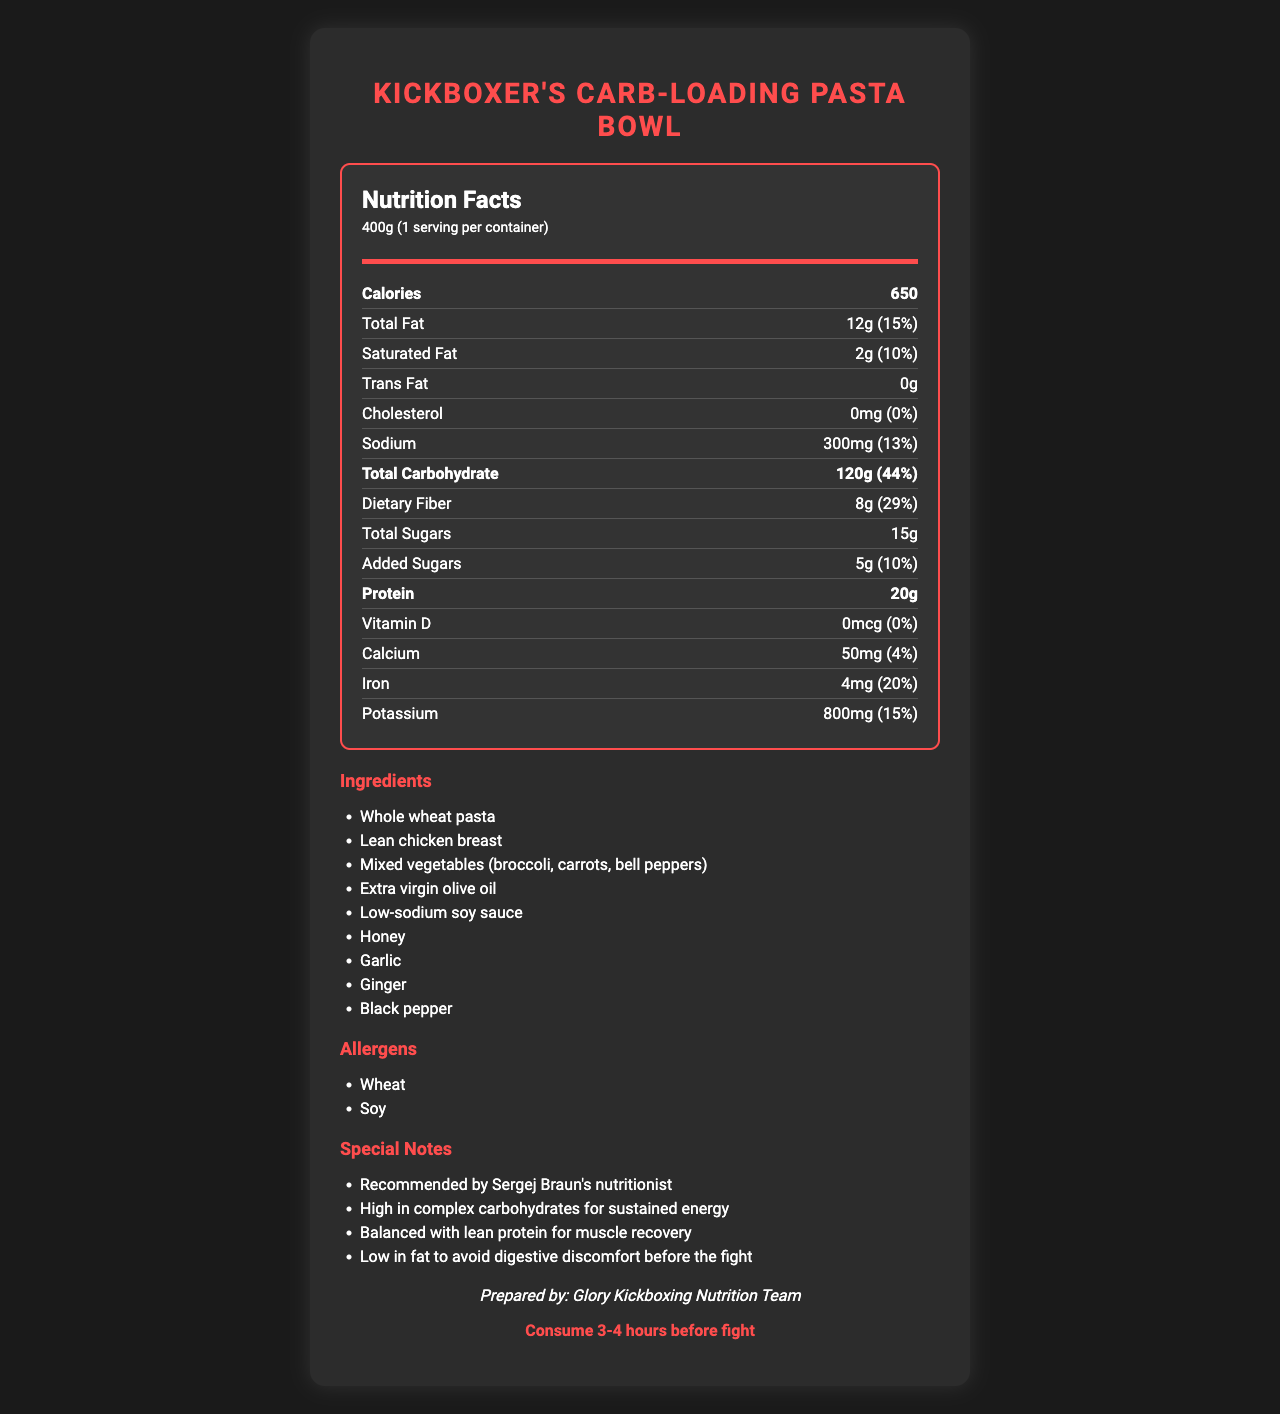what is the serving size? The serving size is clearly mentioned as 400g in the nutrition facts section.
Answer: 400g how much protein does the meal contain per serving? The nutrition facts indicate that each serving contains 20g of protein.
Answer: 20g what are the ingredients used in the meal? The document lists all the ingredients used in the meal under the ingredients section.
Answer: Whole wheat pasta, Lean chicken breast, Mixed vegetables (broccoli, carrots, bell peppers), Extra virgin olive oil, Low-sodium soy sauce, Honey, Garlic, Ginger, Black pepper how much sodium is in the meal? Sodium content is listed as 300mg in the nutrition facts section.
Answer: 300mg what percentage of the daily value of iron does the meal provide? The nutrition facts specify that the meal provides 20% of the daily value of iron.
Answer: 20% which item is NOT an allergen present in the meal? A. Soy B. Peanuts C. Wheat D. None The allergens listed are Wheat and Soy. Peanuts are not mentioned, thus they are not an allergen in the meal.
Answer: B is this meal high in carbohydrates? The meal contains 120g of total carbohydrates, which is 44% of the daily value. This is considered high.
Answer: Yes who prepared this meal? The document states that the meal was prepared by the Glory Kickboxing Nutrition Team.
Answer: Glory Kickboxing Nutrition Team when should this meal be consumed? The document clearly states the consumption time as 3-4 hours before the fight.
Answer: 3-4 hours before the fight summarize the main idea of the document. The document contains comprehensive details about a specific carbohydrate-loading meal intended for kickboxers, detailing its nutritional content, ingredients, preparation, and consumption guidelines.
Answer: The document provides detailed nutritional information for the "Kickboxer's Carb-Loading Pasta Bowl," a meal recommended by Sergej Braun's nutritionist. It includes serving size, calorie count, macronutrient and micronutrient content, ingredients, allergens, and special notes. It emphasizes high carbohydrates and balanced protein to fuel kickboxers for their fights, prepared by the Glory Kickboxing Nutrition Team. Consumption is suggested 3-4 hours before a fight. how many calories does the meal provide? The meal provides 650 calories per serving, as noted in the nutrition facts section.
Answer: 650 what is the fiber content of this meal? The nutrition facts section lists the dietary fiber content as 8g.
Answer: 8g which one of these is a special note mentioned in the document? A. High in fat for more energy B. Balanced with lean protein for muscle recovery C. Contains caffeine to boost energy levels The special notes mention that the meal is balanced with lean protein for muscle recovery.
Answer: B how many grams of added sugars are in this meal? The nutrition facts section indicates that there are 5g of added sugars in the meal.
Answer: 5g is there any trans fat in this meal? The document clearly states that the trans fat content is 0g.
Answer: No what type of pasta is used in this carbohydrate-loading meal? The ingredients list specifies that whole wheat pasta is used in the meal.
Answer: Whole wheat pasta who recommended this meal? A special note mentions that the meal is recommended by Sergej Braun's nutritionist.
Answer: Sergej Braun's nutritionist how many servings per container are there? The document states that there is 1 serving per container.
Answer: 1 